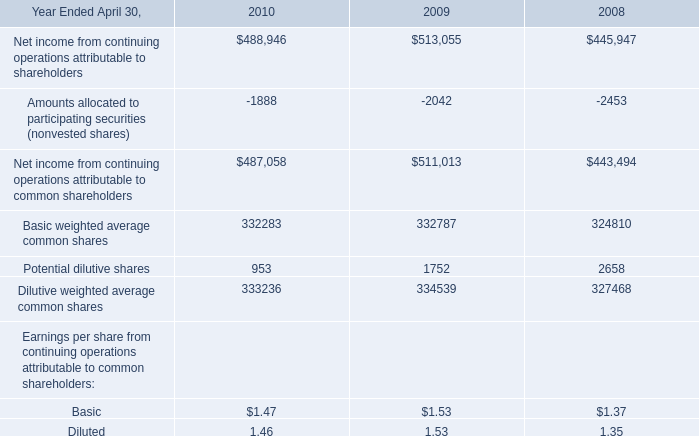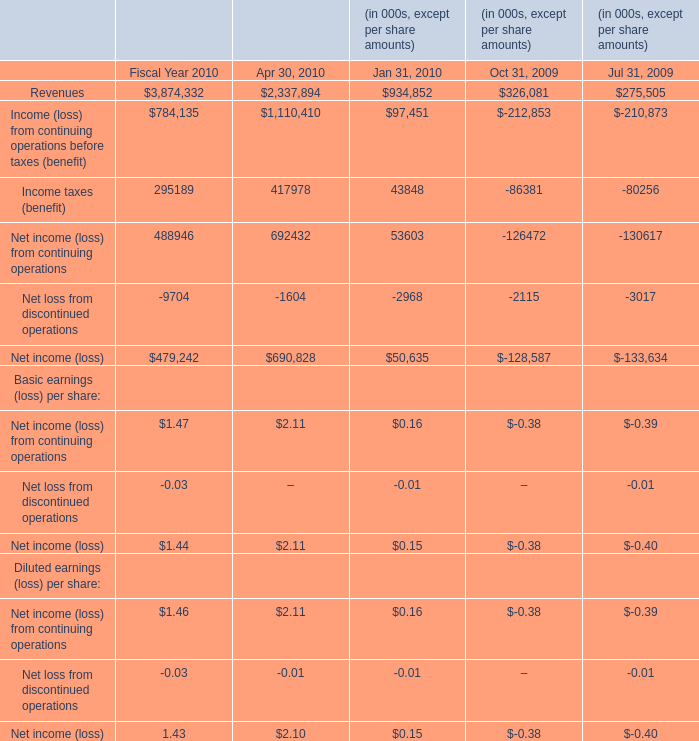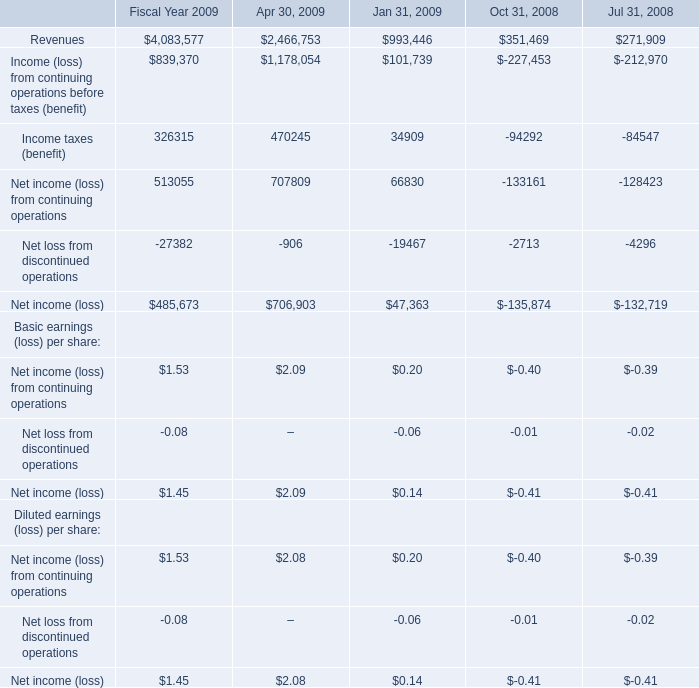In the section with largest amount of Revenues, what's the sum of Diluted earnings (loss) per share:? 
Computations: (1.46 - 0.03)
Answer: 1.43. 